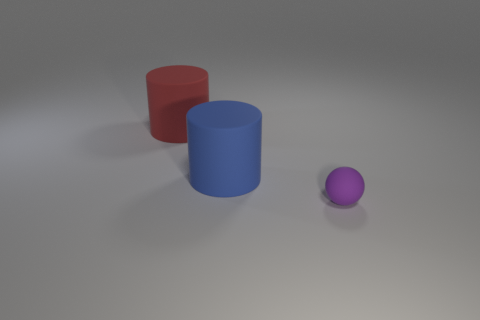How many green objects are either rubber things or large rubber cylinders?
Your answer should be compact. 0. How many other things are the same color as the ball?
Ensure brevity in your answer.  0. Are there fewer large purple things than matte spheres?
Offer a terse response. Yes. There is a big cylinder to the right of the large cylinder to the left of the big blue object; how many purple things are in front of it?
Offer a terse response. 1. There is a cylinder right of the red matte object; what size is it?
Ensure brevity in your answer.  Large. Is the shape of the big matte object right of the red cylinder the same as  the purple thing?
Make the answer very short. No. Are there any other things that are the same size as the ball?
Make the answer very short. No. Are any brown rubber cylinders visible?
Your answer should be very brief. No. Does the big blue rubber object have the same shape as the thing behind the large blue matte object?
Your answer should be very brief. Yes. What number of other big things have the same shape as the red object?
Provide a succinct answer. 1. 